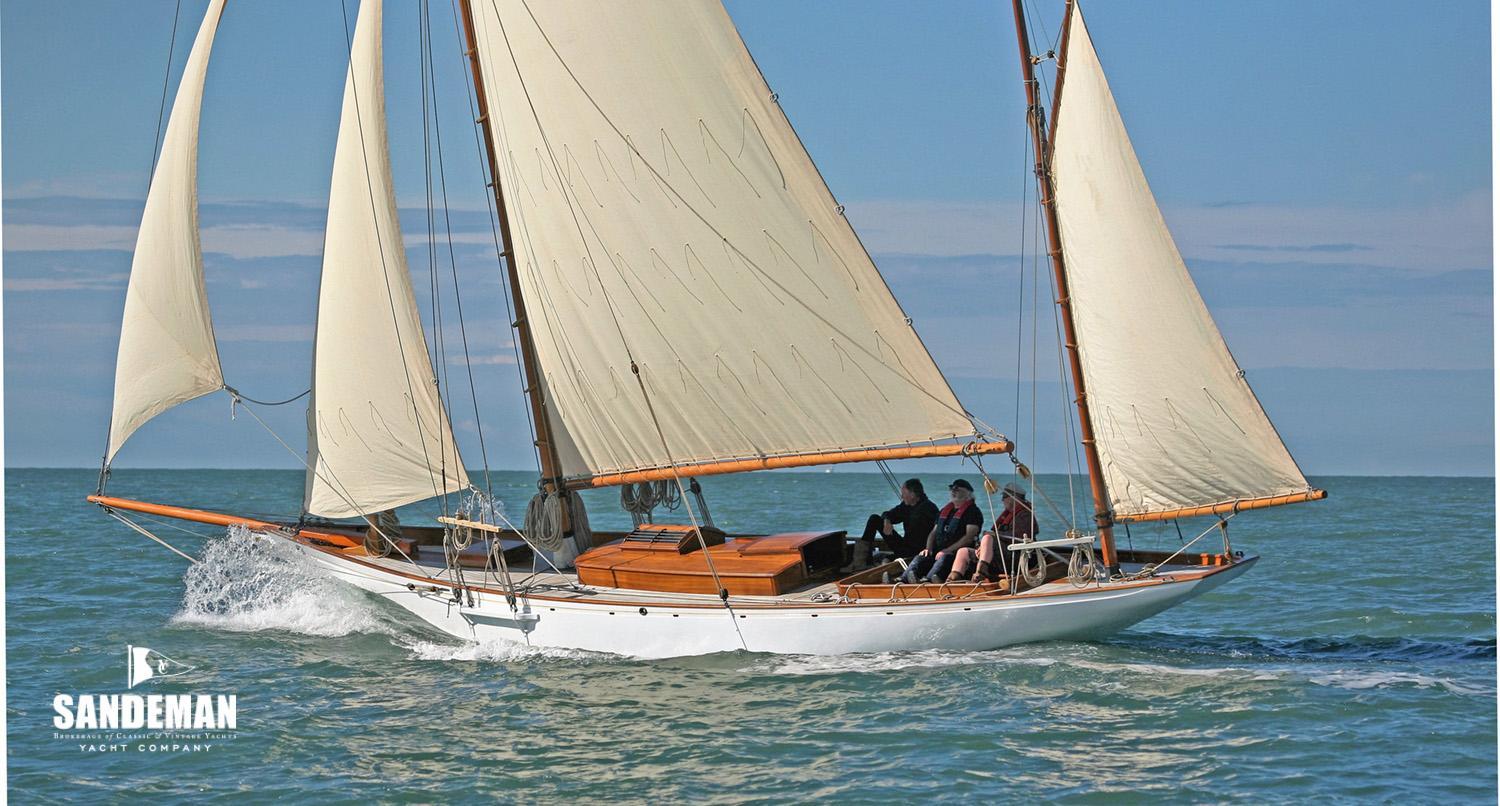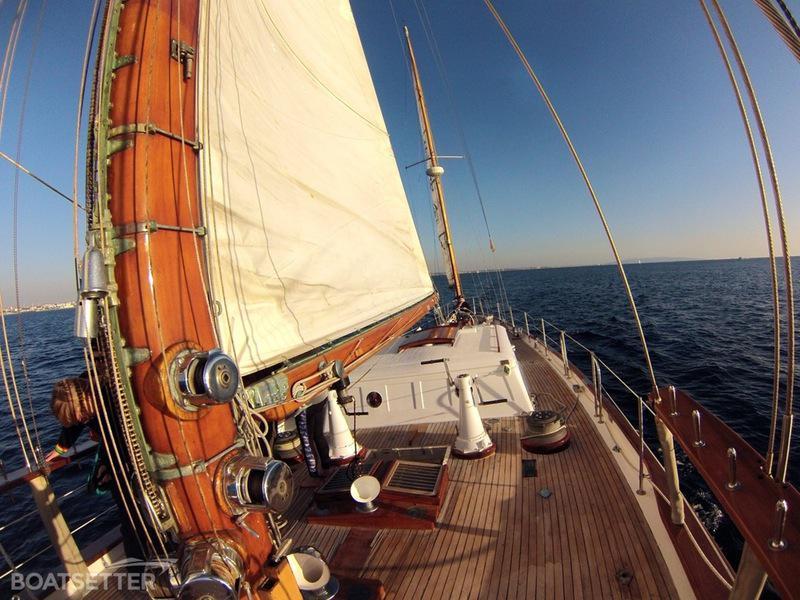The first image is the image on the left, the second image is the image on the right. Assess this claim about the two images: "Two sailboats on open water are headed in the same direction, but only one has a flag flying from the stern.". Correct or not? Answer yes or no. No. 